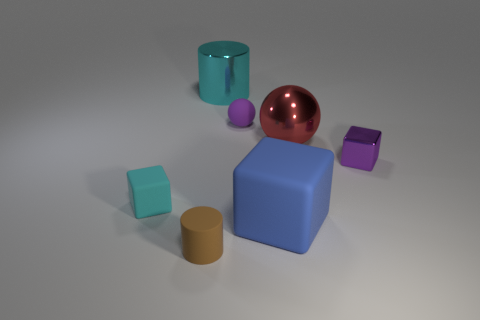What is the shape of the thing that is right of the large blue rubber cube and behind the small metal block?
Keep it short and to the point. Sphere. Is there a cube that has the same material as the large cylinder?
Your answer should be compact. Yes. There is a matte sphere that is the same color as the small metallic block; what size is it?
Provide a short and direct response. Small. What is the color of the tiny matte thing left of the small rubber cylinder?
Provide a short and direct response. Cyan. There is a small cyan object; is it the same shape as the large shiny object in front of the purple ball?
Offer a very short reply. No. Is there a large object of the same color as the tiny matte block?
Your answer should be very brief. Yes. There is a blue object that is the same material as the cyan cube; what is its size?
Your answer should be compact. Large. Is the large shiny cylinder the same color as the small shiny block?
Offer a terse response. No. There is a tiny rubber object left of the brown matte object; does it have the same shape as the big red object?
Keep it short and to the point. No. How many cyan metallic cylinders have the same size as the blue matte cube?
Keep it short and to the point. 1. 